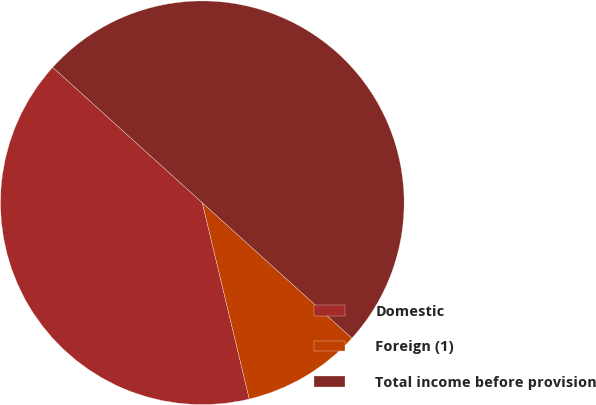Convert chart to OTSL. <chart><loc_0><loc_0><loc_500><loc_500><pie_chart><fcel>Domestic<fcel>Foreign (1)<fcel>Total income before provision<nl><fcel>40.45%<fcel>9.55%<fcel>50.0%<nl></chart> 